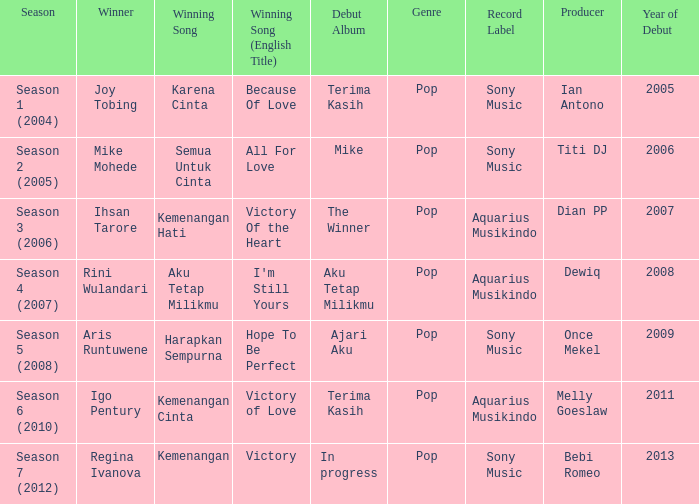Which winning song had a debut album in progress? Kemenangan. 